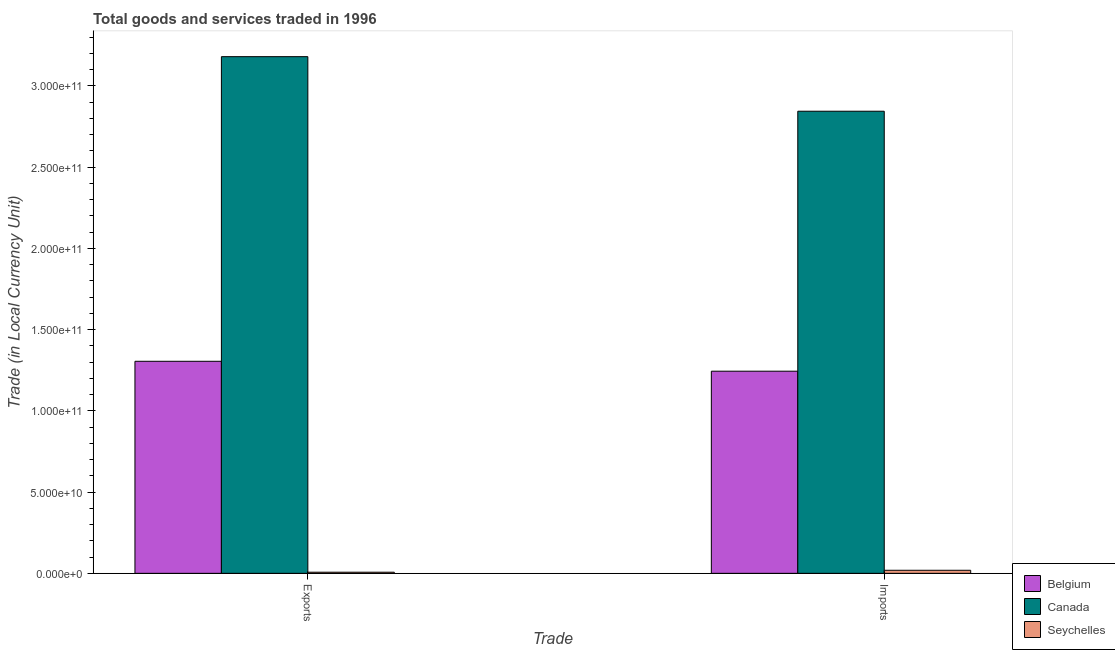Are the number of bars per tick equal to the number of legend labels?
Provide a succinct answer. Yes. Are the number of bars on each tick of the X-axis equal?
Keep it short and to the point. Yes. How many bars are there on the 1st tick from the right?
Make the answer very short. 3. What is the label of the 1st group of bars from the left?
Keep it short and to the point. Exports. What is the imports of goods and services in Seychelles?
Your response must be concise. 1.88e+09. Across all countries, what is the maximum export of goods and services?
Your response must be concise. 3.18e+11. Across all countries, what is the minimum export of goods and services?
Make the answer very short. 6.93e+08. In which country was the imports of goods and services minimum?
Your response must be concise. Seychelles. What is the total imports of goods and services in the graph?
Your answer should be compact. 4.11e+11. What is the difference between the export of goods and services in Canada and that in Seychelles?
Give a very brief answer. 3.17e+11. What is the difference between the export of goods and services in Canada and the imports of goods and services in Belgium?
Offer a very short reply. 1.94e+11. What is the average export of goods and services per country?
Make the answer very short. 1.50e+11. What is the difference between the export of goods and services and imports of goods and services in Canada?
Provide a succinct answer. 3.36e+1. What is the ratio of the imports of goods and services in Canada to that in Belgium?
Give a very brief answer. 2.29. In how many countries, is the imports of goods and services greater than the average imports of goods and services taken over all countries?
Offer a very short reply. 1. What does the 3rd bar from the left in Exports represents?
Provide a succinct answer. Seychelles. How many countries are there in the graph?
Your answer should be compact. 3. Are the values on the major ticks of Y-axis written in scientific E-notation?
Your answer should be very brief. Yes. Does the graph contain grids?
Offer a very short reply. No. Where does the legend appear in the graph?
Offer a terse response. Bottom right. What is the title of the graph?
Provide a short and direct response. Total goods and services traded in 1996. Does "Albania" appear as one of the legend labels in the graph?
Make the answer very short. No. What is the label or title of the X-axis?
Provide a succinct answer. Trade. What is the label or title of the Y-axis?
Provide a succinct answer. Trade (in Local Currency Unit). What is the Trade (in Local Currency Unit) of Belgium in Exports?
Provide a succinct answer. 1.31e+11. What is the Trade (in Local Currency Unit) of Canada in Exports?
Offer a terse response. 3.18e+11. What is the Trade (in Local Currency Unit) in Seychelles in Exports?
Provide a succinct answer. 6.93e+08. What is the Trade (in Local Currency Unit) of Belgium in Imports?
Ensure brevity in your answer.  1.24e+11. What is the Trade (in Local Currency Unit) of Canada in Imports?
Offer a very short reply. 2.84e+11. What is the Trade (in Local Currency Unit) of Seychelles in Imports?
Keep it short and to the point. 1.88e+09. Across all Trade, what is the maximum Trade (in Local Currency Unit) in Belgium?
Give a very brief answer. 1.31e+11. Across all Trade, what is the maximum Trade (in Local Currency Unit) of Canada?
Your answer should be very brief. 3.18e+11. Across all Trade, what is the maximum Trade (in Local Currency Unit) of Seychelles?
Offer a very short reply. 1.88e+09. Across all Trade, what is the minimum Trade (in Local Currency Unit) in Belgium?
Provide a short and direct response. 1.24e+11. Across all Trade, what is the minimum Trade (in Local Currency Unit) of Canada?
Keep it short and to the point. 2.84e+11. Across all Trade, what is the minimum Trade (in Local Currency Unit) in Seychelles?
Keep it short and to the point. 6.93e+08. What is the total Trade (in Local Currency Unit) of Belgium in the graph?
Ensure brevity in your answer.  2.55e+11. What is the total Trade (in Local Currency Unit) of Canada in the graph?
Offer a very short reply. 6.02e+11. What is the total Trade (in Local Currency Unit) in Seychelles in the graph?
Provide a short and direct response. 2.58e+09. What is the difference between the Trade (in Local Currency Unit) in Belgium in Exports and that in Imports?
Your response must be concise. 6.10e+09. What is the difference between the Trade (in Local Currency Unit) in Canada in Exports and that in Imports?
Make the answer very short. 3.36e+1. What is the difference between the Trade (in Local Currency Unit) of Seychelles in Exports and that in Imports?
Keep it short and to the point. -1.19e+09. What is the difference between the Trade (in Local Currency Unit) of Belgium in Exports and the Trade (in Local Currency Unit) of Canada in Imports?
Provide a succinct answer. -1.54e+11. What is the difference between the Trade (in Local Currency Unit) in Belgium in Exports and the Trade (in Local Currency Unit) in Seychelles in Imports?
Make the answer very short. 1.29e+11. What is the difference between the Trade (in Local Currency Unit) in Canada in Exports and the Trade (in Local Currency Unit) in Seychelles in Imports?
Your response must be concise. 3.16e+11. What is the average Trade (in Local Currency Unit) of Belgium per Trade?
Your answer should be very brief. 1.27e+11. What is the average Trade (in Local Currency Unit) in Canada per Trade?
Give a very brief answer. 3.01e+11. What is the average Trade (in Local Currency Unit) of Seychelles per Trade?
Your answer should be compact. 1.29e+09. What is the difference between the Trade (in Local Currency Unit) of Belgium and Trade (in Local Currency Unit) of Canada in Exports?
Offer a terse response. -1.88e+11. What is the difference between the Trade (in Local Currency Unit) in Belgium and Trade (in Local Currency Unit) in Seychelles in Exports?
Your response must be concise. 1.30e+11. What is the difference between the Trade (in Local Currency Unit) of Canada and Trade (in Local Currency Unit) of Seychelles in Exports?
Ensure brevity in your answer.  3.17e+11. What is the difference between the Trade (in Local Currency Unit) of Belgium and Trade (in Local Currency Unit) of Canada in Imports?
Give a very brief answer. -1.60e+11. What is the difference between the Trade (in Local Currency Unit) in Belgium and Trade (in Local Currency Unit) in Seychelles in Imports?
Provide a succinct answer. 1.23e+11. What is the difference between the Trade (in Local Currency Unit) in Canada and Trade (in Local Currency Unit) in Seychelles in Imports?
Offer a terse response. 2.83e+11. What is the ratio of the Trade (in Local Currency Unit) in Belgium in Exports to that in Imports?
Offer a terse response. 1.05. What is the ratio of the Trade (in Local Currency Unit) of Canada in Exports to that in Imports?
Your answer should be compact. 1.12. What is the ratio of the Trade (in Local Currency Unit) in Seychelles in Exports to that in Imports?
Provide a succinct answer. 0.37. What is the difference between the highest and the second highest Trade (in Local Currency Unit) of Belgium?
Offer a very short reply. 6.10e+09. What is the difference between the highest and the second highest Trade (in Local Currency Unit) of Canada?
Keep it short and to the point. 3.36e+1. What is the difference between the highest and the second highest Trade (in Local Currency Unit) in Seychelles?
Provide a short and direct response. 1.19e+09. What is the difference between the highest and the lowest Trade (in Local Currency Unit) of Belgium?
Your answer should be compact. 6.10e+09. What is the difference between the highest and the lowest Trade (in Local Currency Unit) in Canada?
Your answer should be compact. 3.36e+1. What is the difference between the highest and the lowest Trade (in Local Currency Unit) in Seychelles?
Keep it short and to the point. 1.19e+09. 